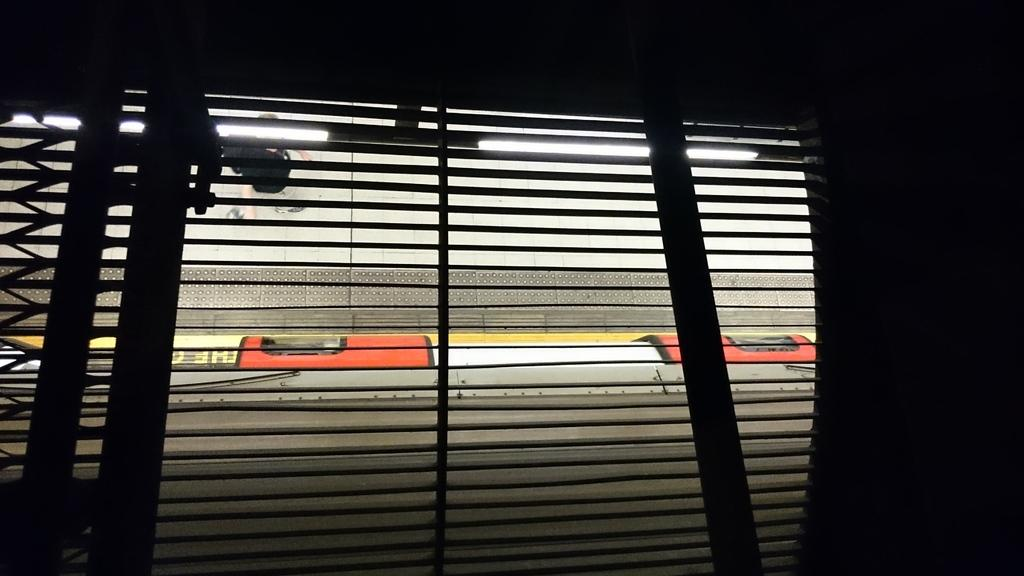What can be seen on the right side of the image? There is a wall to the right side of the image. What architectural feature is visible in the image? There is a window in the image. What type of tooth is visible in the image? There is no tooth present in the image. What type of twig can be seen growing near the window in the image? There is no twig visible in the image; only the window and wall are present. 